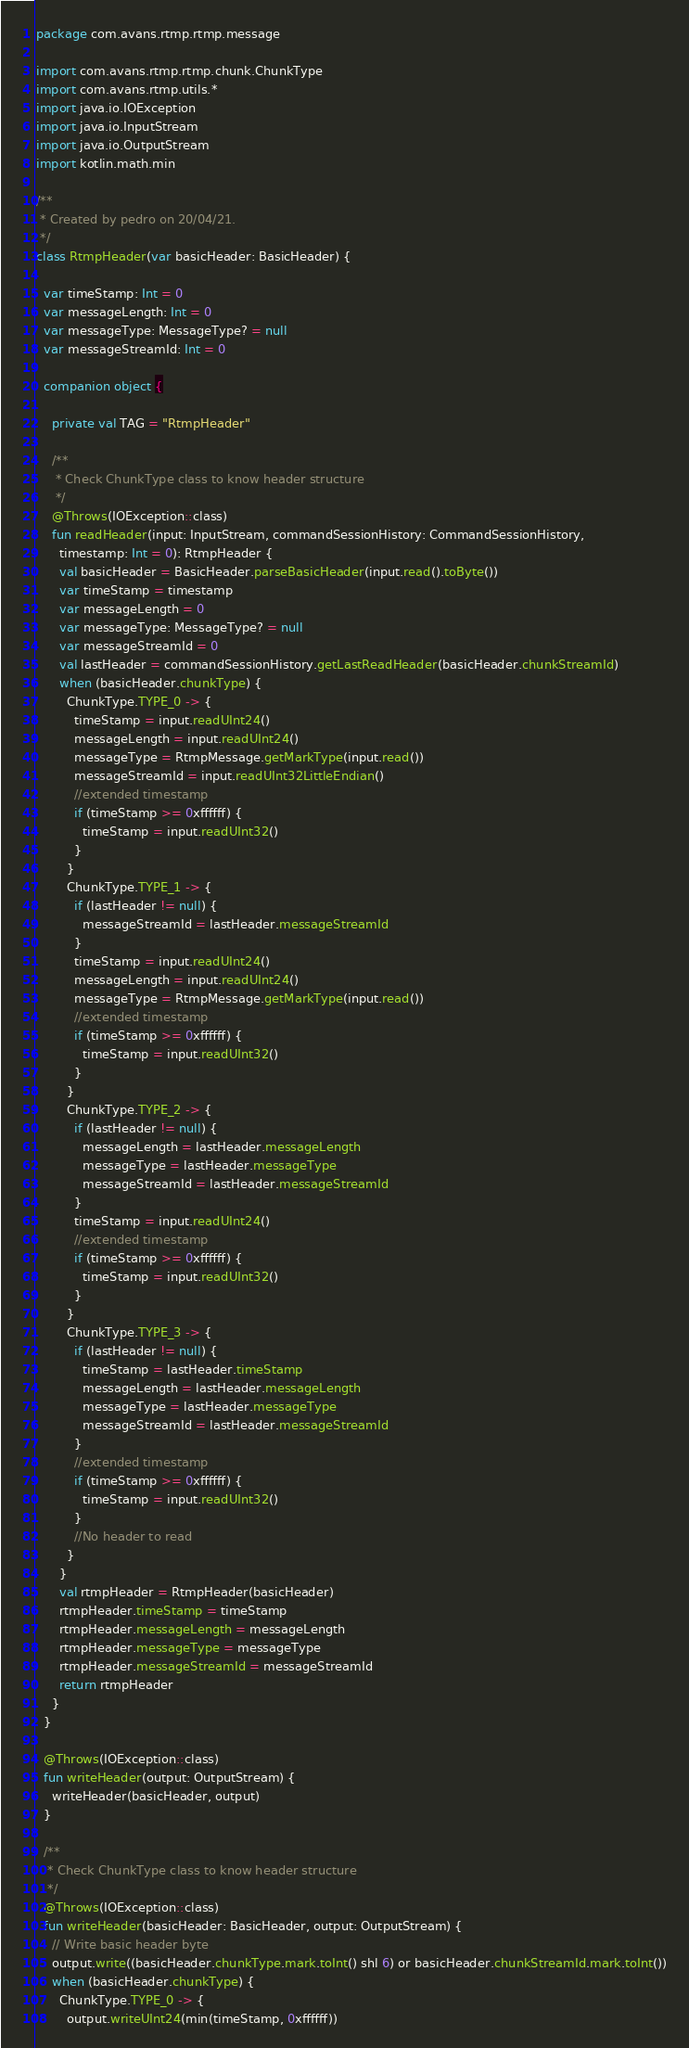<code> <loc_0><loc_0><loc_500><loc_500><_Kotlin_>package com.avans.rtmp.rtmp.message

import com.avans.rtmp.rtmp.chunk.ChunkType
import com.avans.rtmp.utils.*
import java.io.IOException
import java.io.InputStream
import java.io.OutputStream
import kotlin.math.min

/**
 * Created by pedro on 20/04/21.
 */
class RtmpHeader(var basicHeader: BasicHeader) {

  var timeStamp: Int = 0
  var messageLength: Int = 0
  var messageType: MessageType? = null
  var messageStreamId: Int = 0

  companion object {

    private val TAG = "RtmpHeader"

    /**
     * Check ChunkType class to know header structure
     */
    @Throws(IOException::class)
    fun readHeader(input: InputStream, commandSessionHistory: CommandSessionHistory,
      timestamp: Int = 0): RtmpHeader {
      val basicHeader = BasicHeader.parseBasicHeader(input.read().toByte())
      var timeStamp = timestamp
      var messageLength = 0
      var messageType: MessageType? = null
      var messageStreamId = 0
      val lastHeader = commandSessionHistory.getLastReadHeader(basicHeader.chunkStreamId)
      when (basicHeader.chunkType) {
        ChunkType.TYPE_0 -> {
          timeStamp = input.readUInt24()
          messageLength = input.readUInt24()
          messageType = RtmpMessage.getMarkType(input.read())
          messageStreamId = input.readUInt32LittleEndian()
          //extended timestamp
          if (timeStamp >= 0xffffff) {
            timeStamp = input.readUInt32()
          }
        }
        ChunkType.TYPE_1 -> {
          if (lastHeader != null) {
            messageStreamId = lastHeader.messageStreamId
          }
          timeStamp = input.readUInt24()
          messageLength = input.readUInt24()
          messageType = RtmpMessage.getMarkType(input.read())
          //extended timestamp
          if (timeStamp >= 0xffffff) {
            timeStamp = input.readUInt32()
          }
        }
        ChunkType.TYPE_2 -> {
          if (lastHeader != null) {
            messageLength = lastHeader.messageLength
            messageType = lastHeader.messageType
            messageStreamId = lastHeader.messageStreamId
          }
          timeStamp = input.readUInt24()
          //extended timestamp
          if (timeStamp >= 0xffffff) {
            timeStamp = input.readUInt32()
          }
        }
        ChunkType.TYPE_3 -> {
          if (lastHeader != null) {
            timeStamp = lastHeader.timeStamp
            messageLength = lastHeader.messageLength
            messageType = lastHeader.messageType
            messageStreamId = lastHeader.messageStreamId
          }
          //extended timestamp
          if (timeStamp >= 0xffffff) {
            timeStamp = input.readUInt32()
          }
          //No header to read
        }
      }
      val rtmpHeader = RtmpHeader(basicHeader)
      rtmpHeader.timeStamp = timeStamp
      rtmpHeader.messageLength = messageLength
      rtmpHeader.messageType = messageType
      rtmpHeader.messageStreamId = messageStreamId
      return rtmpHeader
    }
  }

  @Throws(IOException::class)
  fun writeHeader(output: OutputStream) {
    writeHeader(basicHeader, output)
  }

  /**
   * Check ChunkType class to know header structure
   */
  @Throws(IOException::class)
  fun writeHeader(basicHeader: BasicHeader, output: OutputStream) {
    // Write basic header byte
    output.write((basicHeader.chunkType.mark.toInt() shl 6) or basicHeader.chunkStreamId.mark.toInt())
    when (basicHeader.chunkType) {
      ChunkType.TYPE_0 -> {
        output.writeUInt24(min(timeStamp, 0xffffff))</code> 